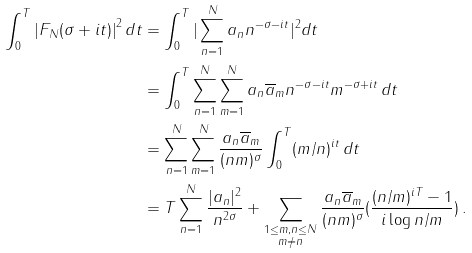Convert formula to latex. <formula><loc_0><loc_0><loc_500><loc_500>\int _ { 0 } ^ { T } { | F _ { N } ( \sigma + i t ) | } ^ { 2 } \, d t & = \int _ { 0 } ^ { T } | \sum _ { n = 1 } ^ { N } a _ { n } n ^ { - \sigma - i t } | ^ { 2 } d t \\ & = \int _ { 0 } ^ { T } \sum _ { n = 1 } ^ { N } \sum _ { m = 1 } ^ { N } a _ { n } \overline { a } _ { m } n ^ { - \sigma - i t } m ^ { - \sigma + i t } \, d t \\ & = \sum _ { n = 1 } ^ { N } \sum _ { m = 1 } ^ { N } \frac { a _ { n } \overline { a } _ { m } } { ( n m ) ^ { \sigma } } \int _ { 0 } ^ { T } ( m / n ) ^ { i t } \, d t \\ & = T \sum _ { n = 1 } ^ { N } \frac { | a _ { n } | ^ { 2 } } { n ^ { 2 \sigma } } + \sum _ { \substack { 1 \leq m , n \leq N \\ m \neq n } } \frac { a _ { n } \overline { a } _ { m } } { ( n m ) ^ { \sigma } } ( \frac { ( n / m ) ^ { i T } - 1 } { i \log n / m } ) \, .</formula> 